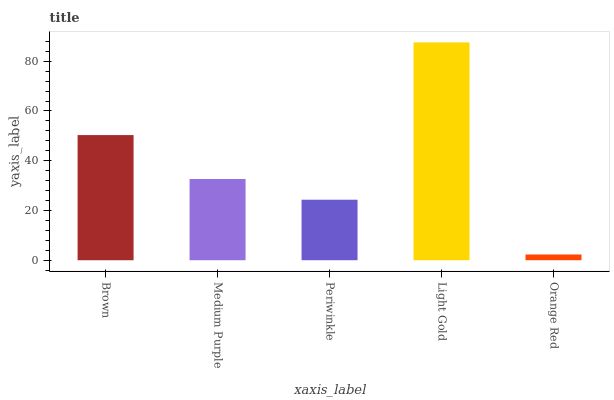Is Orange Red the minimum?
Answer yes or no. Yes. Is Light Gold the maximum?
Answer yes or no. Yes. Is Medium Purple the minimum?
Answer yes or no. No. Is Medium Purple the maximum?
Answer yes or no. No. Is Brown greater than Medium Purple?
Answer yes or no. Yes. Is Medium Purple less than Brown?
Answer yes or no. Yes. Is Medium Purple greater than Brown?
Answer yes or no. No. Is Brown less than Medium Purple?
Answer yes or no. No. Is Medium Purple the high median?
Answer yes or no. Yes. Is Medium Purple the low median?
Answer yes or no. Yes. Is Brown the high median?
Answer yes or no. No. Is Light Gold the low median?
Answer yes or no. No. 